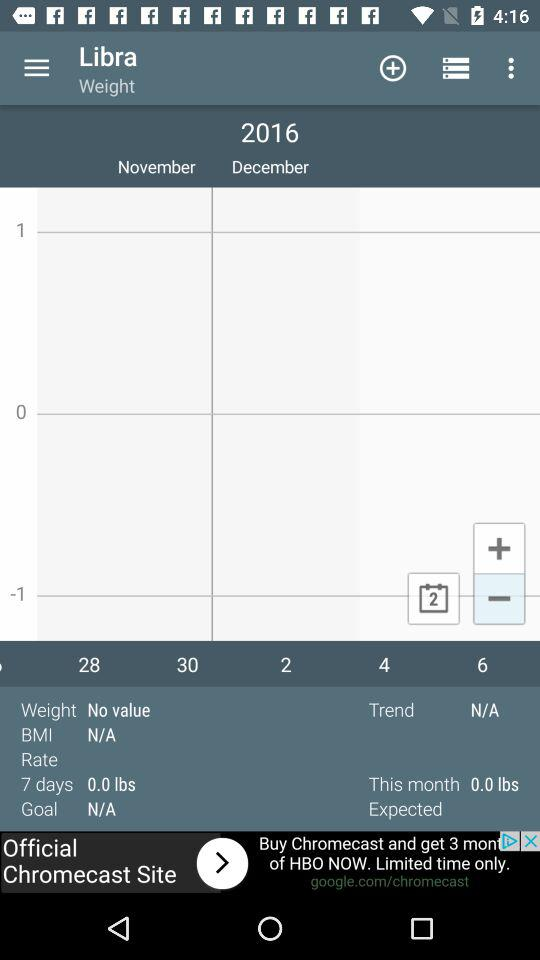What year is mentioned in the calendar? The mentioned year is 2016. 